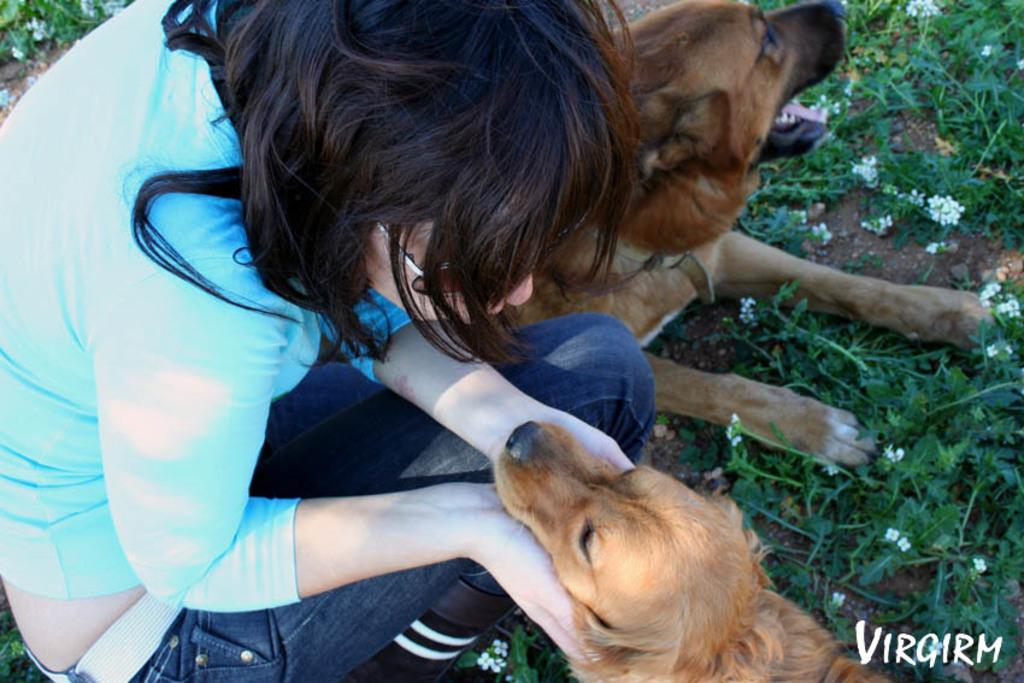Who is present in the image? There is a lady in the image. What animals are in the image? There are dogs in the image. What is the lady doing with one of the dogs? The lady is holding a dog's mouth in her hand. What type of surface is visible on the ground in the image? There is grass on the ground in the image. What discovery did the lady make while holding the dog's mouth in the image? There is no indication of a discovery in the image; the lady is simply holding the dog's mouth. What thing is the lady using to guide the dogs in the image? There is no thing being used to guide the dogs in the image; the lady is only holding one dog's mouth. 